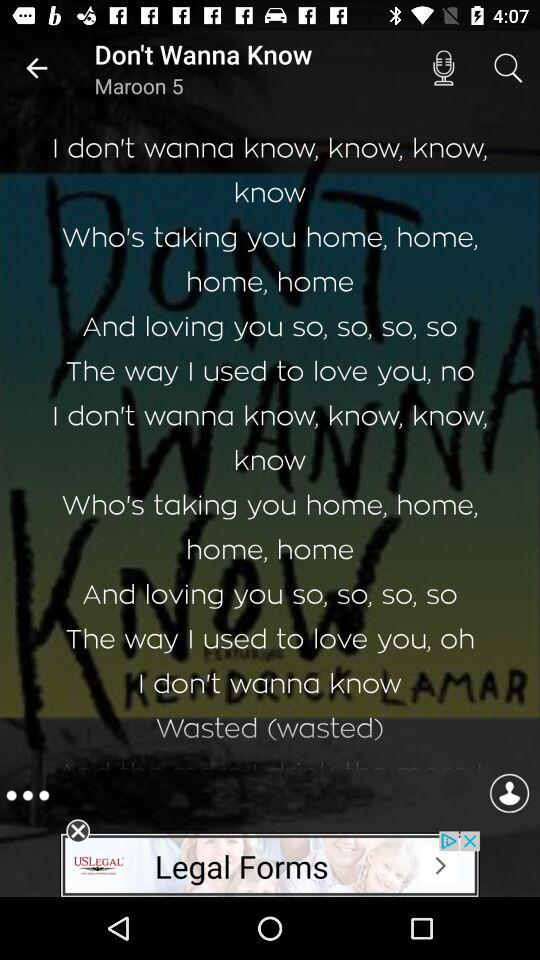What's the title of the song? The title of the song is "Don't Wanna Know". 